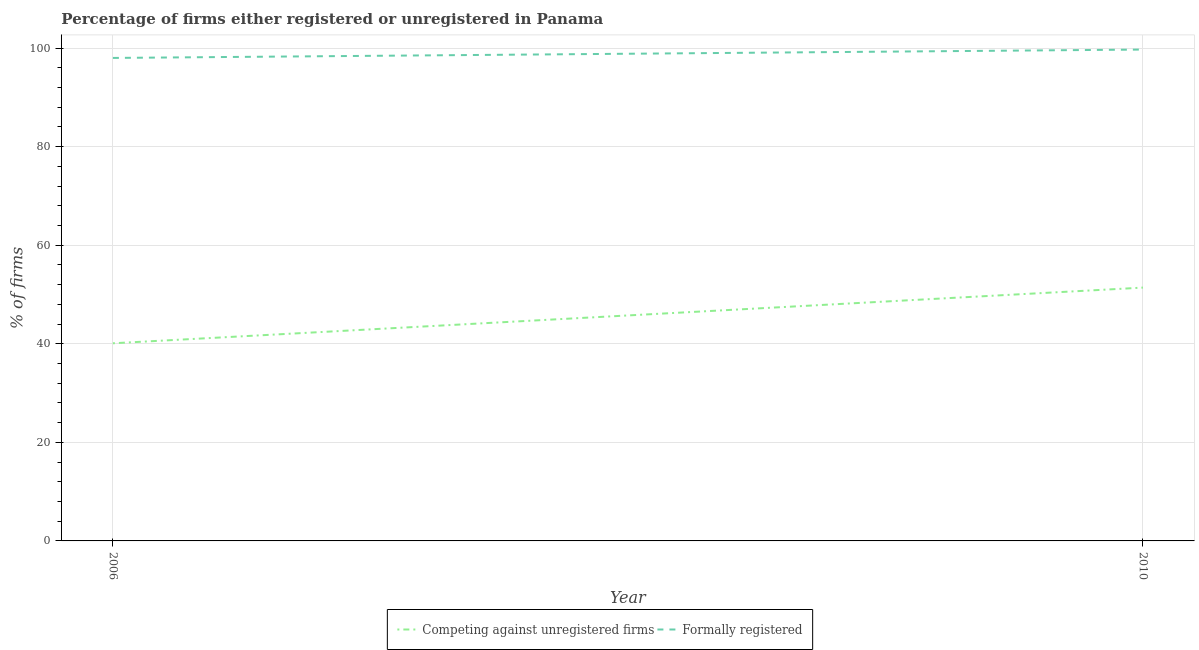Does the line corresponding to percentage of formally registered firms intersect with the line corresponding to percentage of registered firms?
Your response must be concise. No. Is the number of lines equal to the number of legend labels?
Provide a succinct answer. Yes. What is the percentage of registered firms in 2006?
Your answer should be very brief. 40.1. Across all years, what is the maximum percentage of registered firms?
Provide a short and direct response. 51.4. Across all years, what is the minimum percentage of formally registered firms?
Provide a short and direct response. 98. In which year was the percentage of formally registered firms minimum?
Offer a terse response. 2006. What is the total percentage of registered firms in the graph?
Your answer should be very brief. 91.5. What is the difference between the percentage of registered firms in 2006 and that in 2010?
Your response must be concise. -11.3. What is the difference between the percentage of registered firms in 2006 and the percentage of formally registered firms in 2010?
Provide a short and direct response. -59.6. What is the average percentage of registered firms per year?
Ensure brevity in your answer.  45.75. In the year 2010, what is the difference between the percentage of registered firms and percentage of formally registered firms?
Provide a succinct answer. -48.3. What is the ratio of the percentage of registered firms in 2006 to that in 2010?
Offer a terse response. 0.78. Is the percentage of formally registered firms in 2006 less than that in 2010?
Offer a terse response. Yes. Does the percentage of registered firms monotonically increase over the years?
Your response must be concise. Yes. Does the graph contain grids?
Provide a short and direct response. Yes. How many legend labels are there?
Make the answer very short. 2. How are the legend labels stacked?
Your answer should be compact. Horizontal. What is the title of the graph?
Your response must be concise. Percentage of firms either registered or unregistered in Panama. What is the label or title of the X-axis?
Keep it short and to the point. Year. What is the label or title of the Y-axis?
Give a very brief answer. % of firms. What is the % of firms in Competing against unregistered firms in 2006?
Provide a short and direct response. 40.1. What is the % of firms in Formally registered in 2006?
Offer a very short reply. 98. What is the % of firms of Competing against unregistered firms in 2010?
Make the answer very short. 51.4. What is the % of firms in Formally registered in 2010?
Keep it short and to the point. 99.7. Across all years, what is the maximum % of firms in Competing against unregistered firms?
Your answer should be very brief. 51.4. Across all years, what is the maximum % of firms of Formally registered?
Your response must be concise. 99.7. Across all years, what is the minimum % of firms of Competing against unregistered firms?
Provide a succinct answer. 40.1. Across all years, what is the minimum % of firms of Formally registered?
Offer a very short reply. 98. What is the total % of firms of Competing against unregistered firms in the graph?
Make the answer very short. 91.5. What is the total % of firms of Formally registered in the graph?
Provide a short and direct response. 197.7. What is the difference between the % of firms of Competing against unregistered firms in 2006 and the % of firms of Formally registered in 2010?
Offer a terse response. -59.6. What is the average % of firms in Competing against unregistered firms per year?
Your answer should be very brief. 45.75. What is the average % of firms in Formally registered per year?
Your answer should be compact. 98.85. In the year 2006, what is the difference between the % of firms of Competing against unregistered firms and % of firms of Formally registered?
Offer a very short reply. -57.9. In the year 2010, what is the difference between the % of firms in Competing against unregistered firms and % of firms in Formally registered?
Provide a short and direct response. -48.3. What is the ratio of the % of firms of Competing against unregistered firms in 2006 to that in 2010?
Ensure brevity in your answer.  0.78. What is the ratio of the % of firms of Formally registered in 2006 to that in 2010?
Offer a very short reply. 0.98. What is the difference between the highest and the lowest % of firms in Formally registered?
Your answer should be very brief. 1.7. 